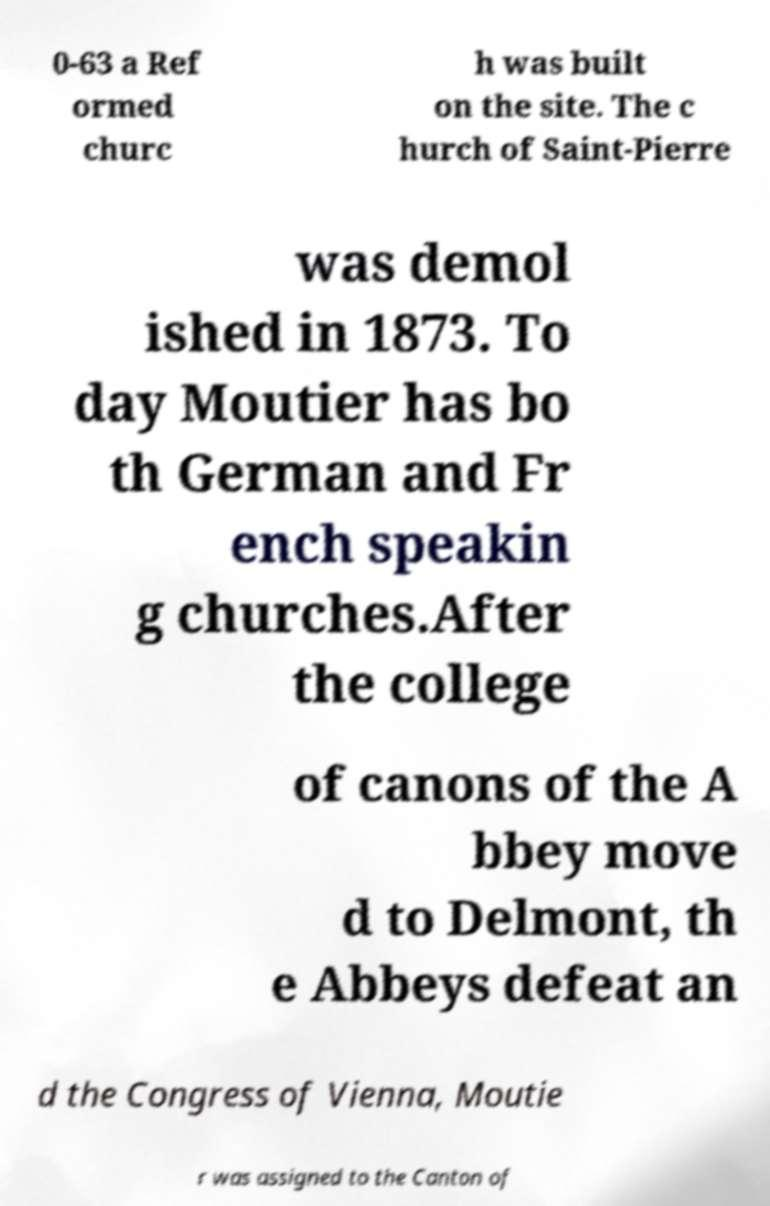Can you read and provide the text displayed in the image?This photo seems to have some interesting text. Can you extract and type it out for me? 0-63 a Ref ormed churc h was built on the site. The c hurch of Saint-Pierre was demol ished in 1873. To day Moutier has bo th German and Fr ench speakin g churches.After the college of canons of the A bbey move d to Delmont, th e Abbeys defeat an d the Congress of Vienna, Moutie r was assigned to the Canton of 